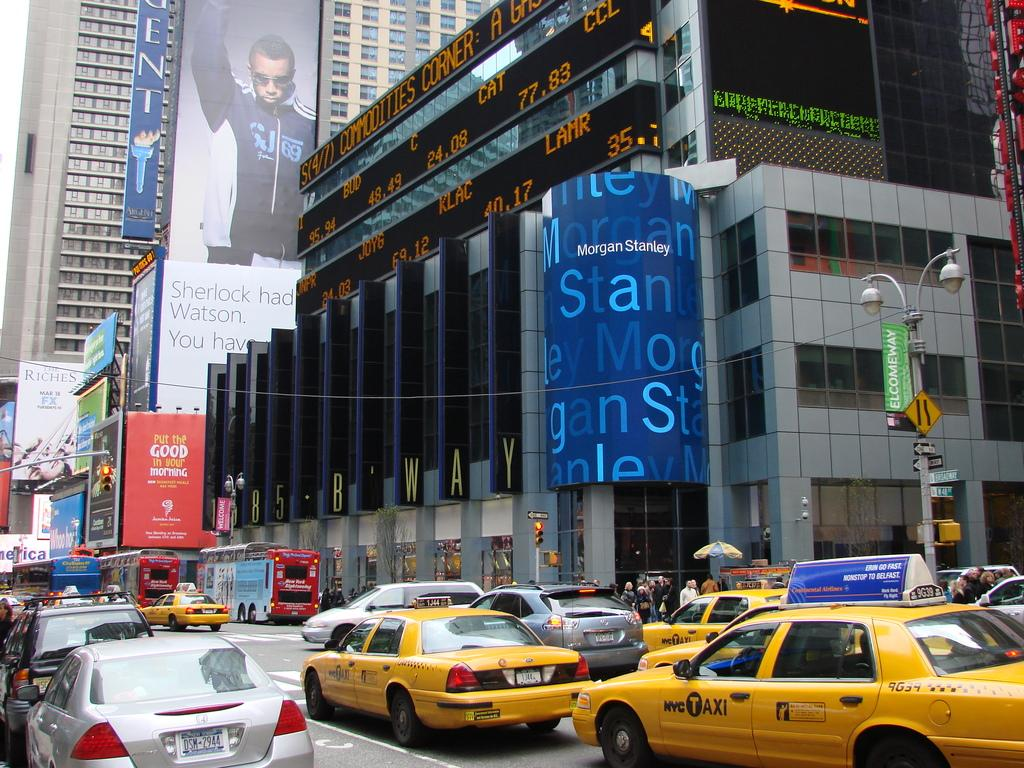<image>
Render a clear and concise summary of the photo. A red sign hanging over the street says to put good in your morning. 